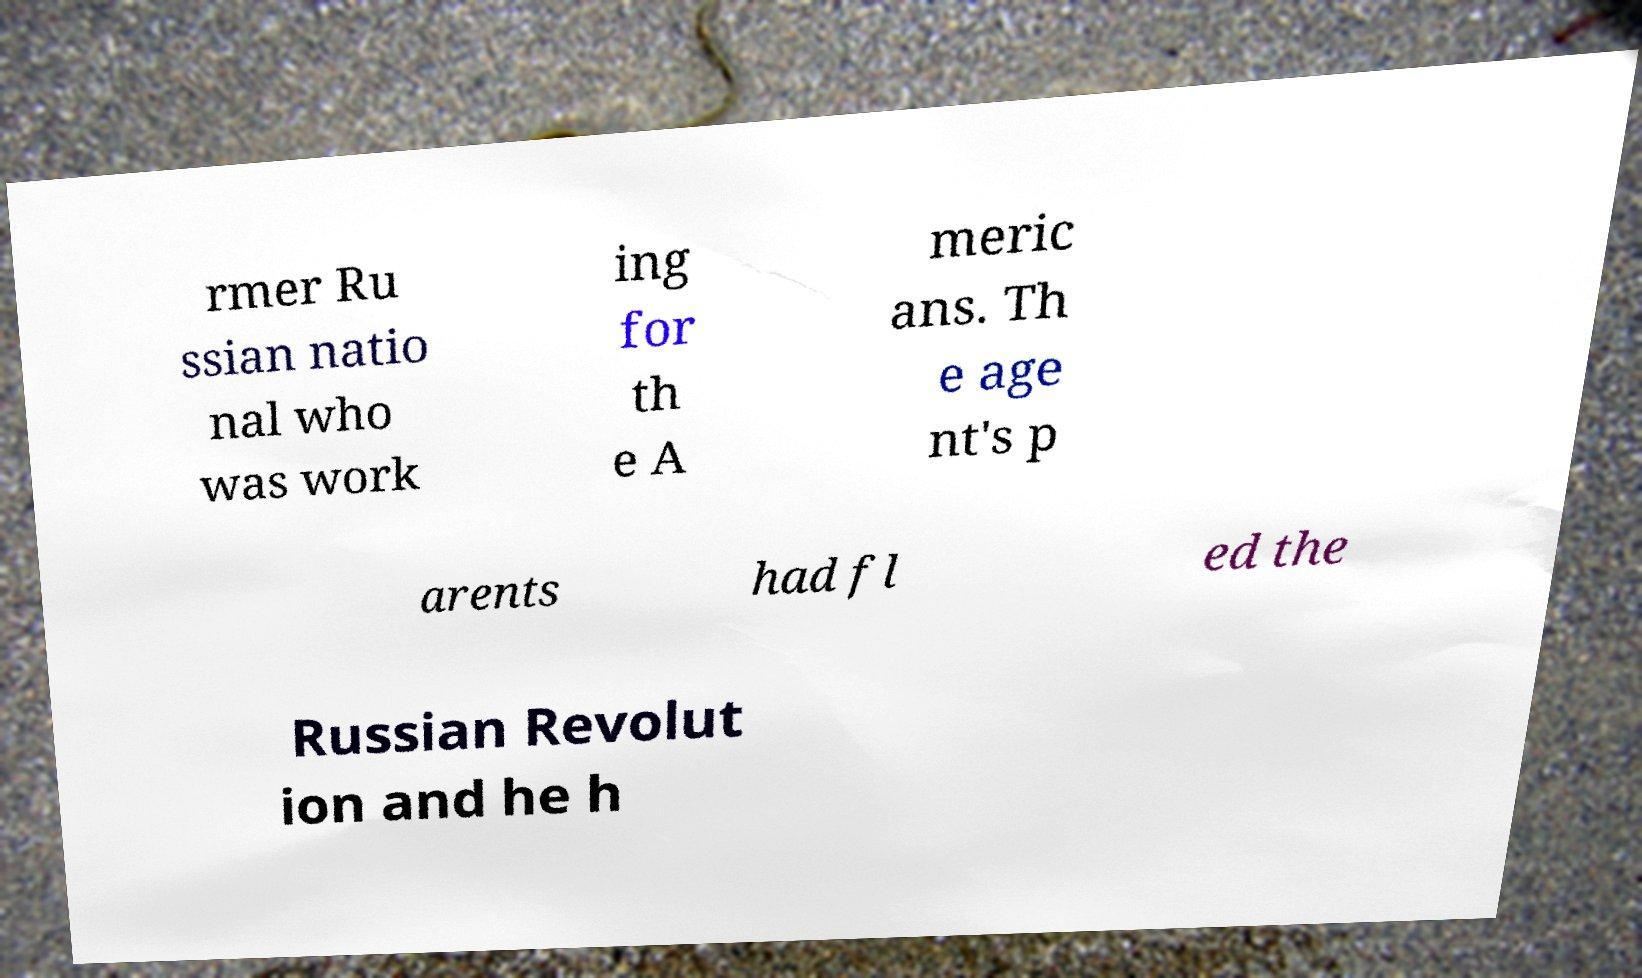For documentation purposes, I need the text within this image transcribed. Could you provide that? rmer Ru ssian natio nal who was work ing for th e A meric ans. Th e age nt's p arents had fl ed the Russian Revolut ion and he h 